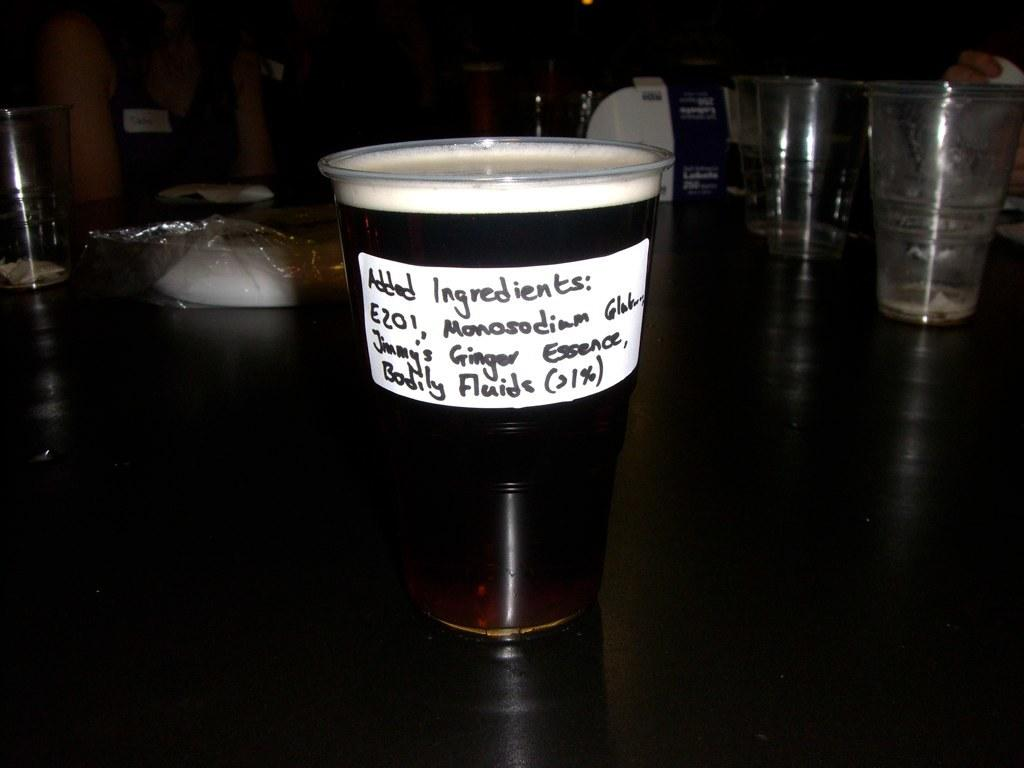<image>
Render a clear and concise summary of the photo. A plastic drinking glass has been labeled with a sticker of ingredients on the side. 